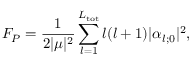Convert formula to latex. <formula><loc_0><loc_0><loc_500><loc_500>F _ { P } = \frac { 1 } { 2 | \mu | ^ { 2 } } \sum _ { l = 1 } ^ { L _ { t o t } } l ( l + 1 ) | \alpha _ { l ; 0 } | ^ { 2 } ,</formula> 